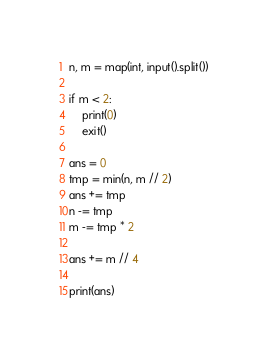<code> <loc_0><loc_0><loc_500><loc_500><_Python_>n, m = map(int, input().split())

if m < 2:
    print(0)
    exit()

ans = 0
tmp = min(n, m // 2)
ans += tmp
n -= tmp
m -= tmp * 2

ans += m // 4

print(ans)</code> 